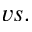Convert formula to latex. <formula><loc_0><loc_0><loc_500><loc_500>v s .</formula> 